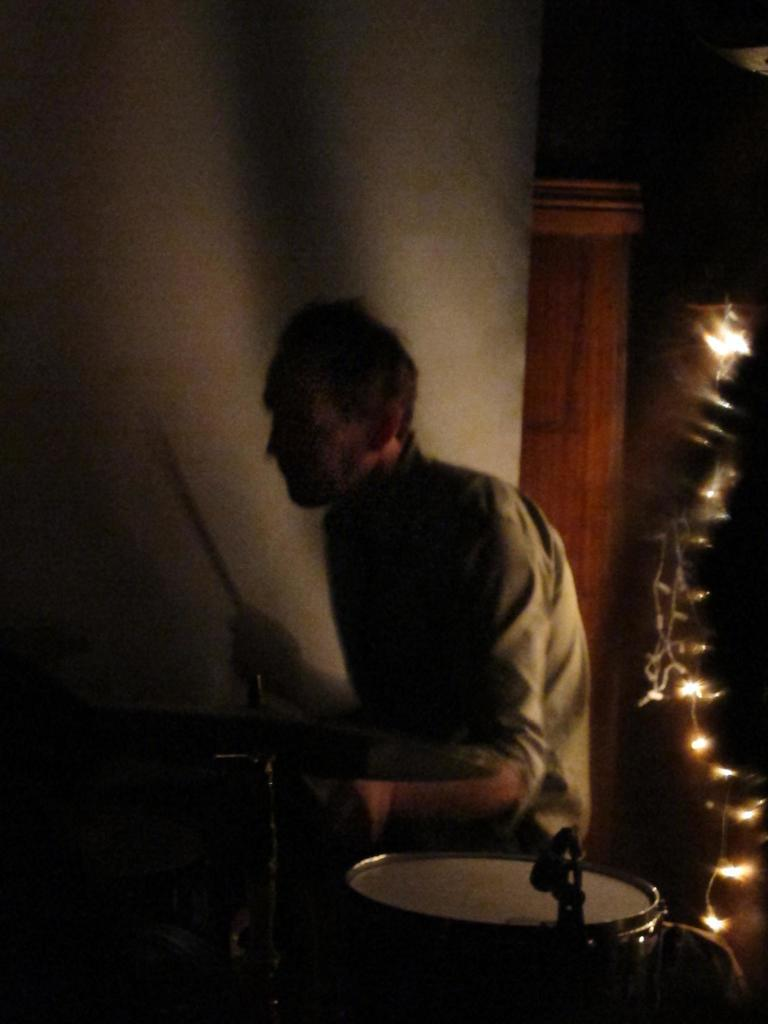What is the man in the image doing? The man is playing drums in the image. What type of instrument is visible next to the man? There is a hi-hat instrument in the image. Can you describe the lighting in the image? There are lights visible in the image. What kind of architectural feature can be seen in the image? There appears to be a wooden pillar in the image. What type of coach is the man using to play the drums in the image? There is no coach present in the image; the man is playing drums directly. 